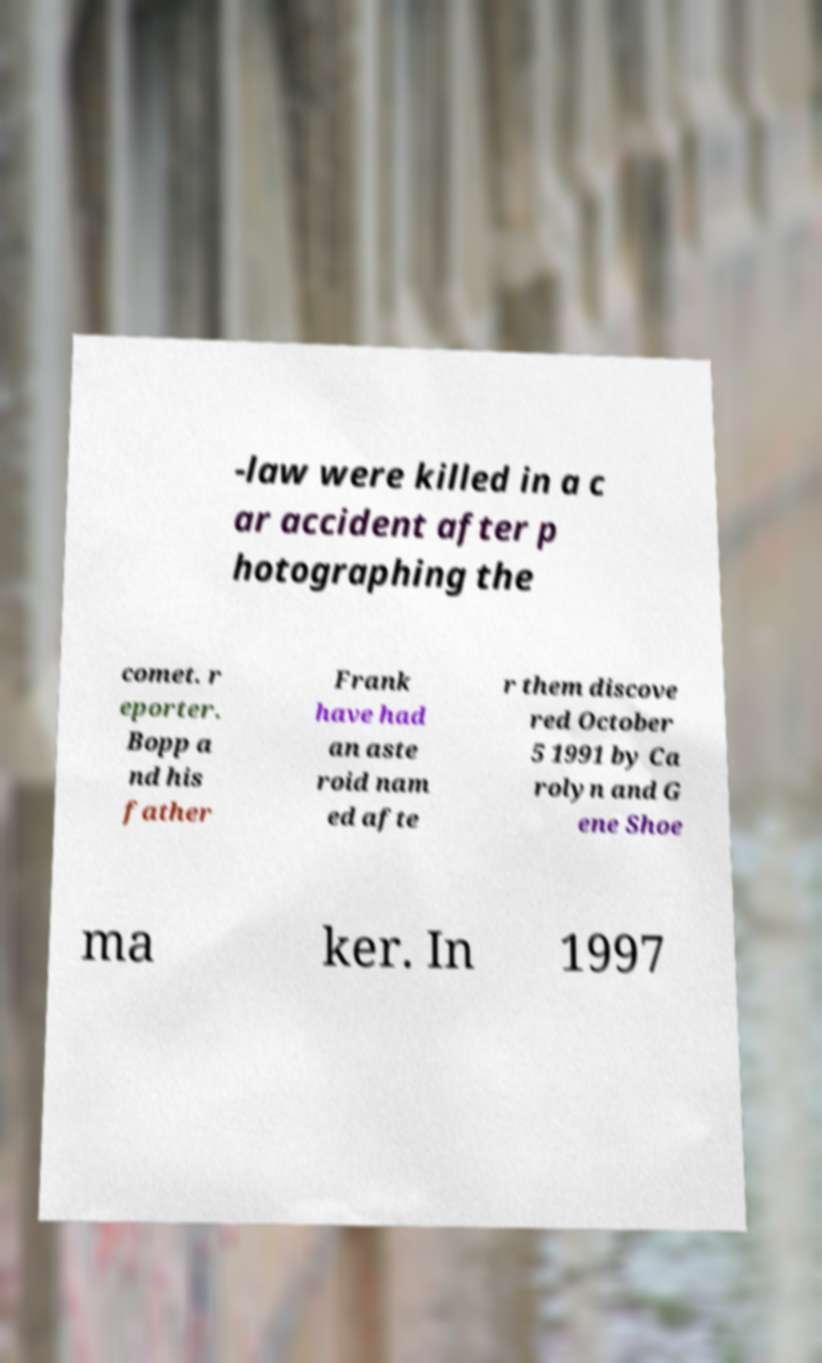Can you read and provide the text displayed in the image?This photo seems to have some interesting text. Can you extract and type it out for me? -law were killed in a c ar accident after p hotographing the comet. r eporter. Bopp a nd his father Frank have had an aste roid nam ed afte r them discove red October 5 1991 by Ca rolyn and G ene Shoe ma ker. In 1997 